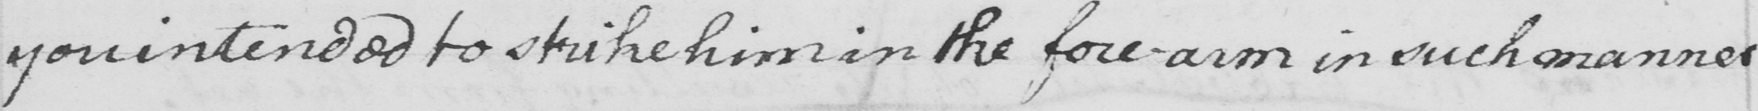Can you tell me what this handwritten text says? you intended to strike him in the fore-arm in such manner 